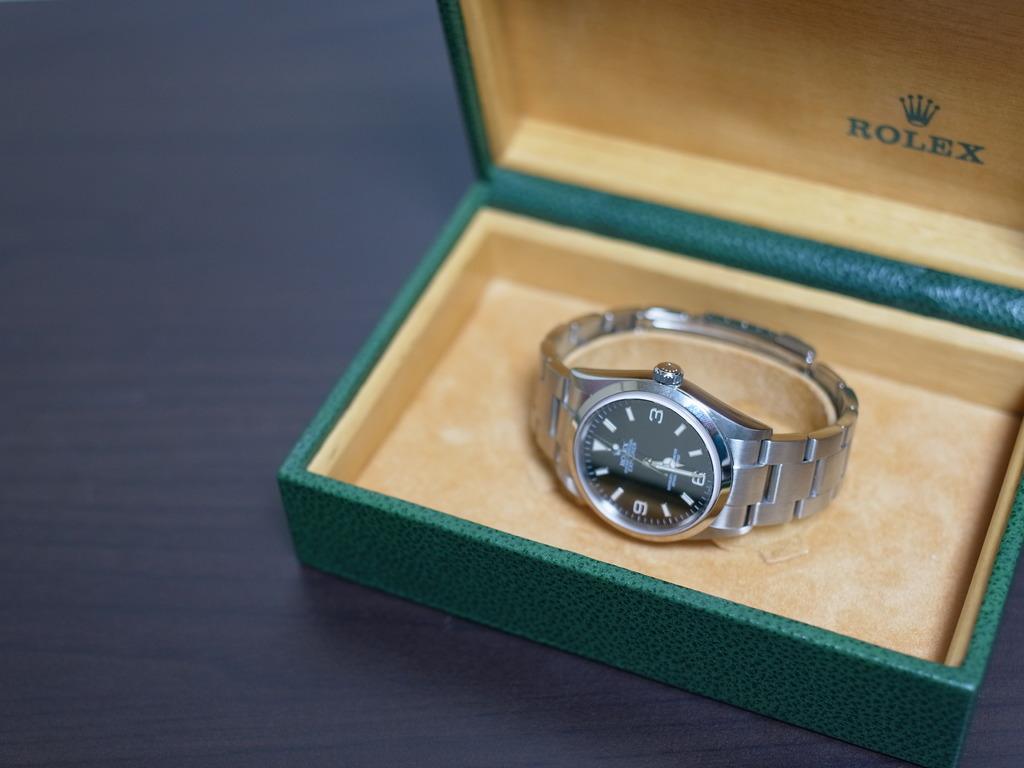What type of watch is that?
Your answer should be very brief. Rolex. What is in the box?
Your answer should be compact. Rolex. 